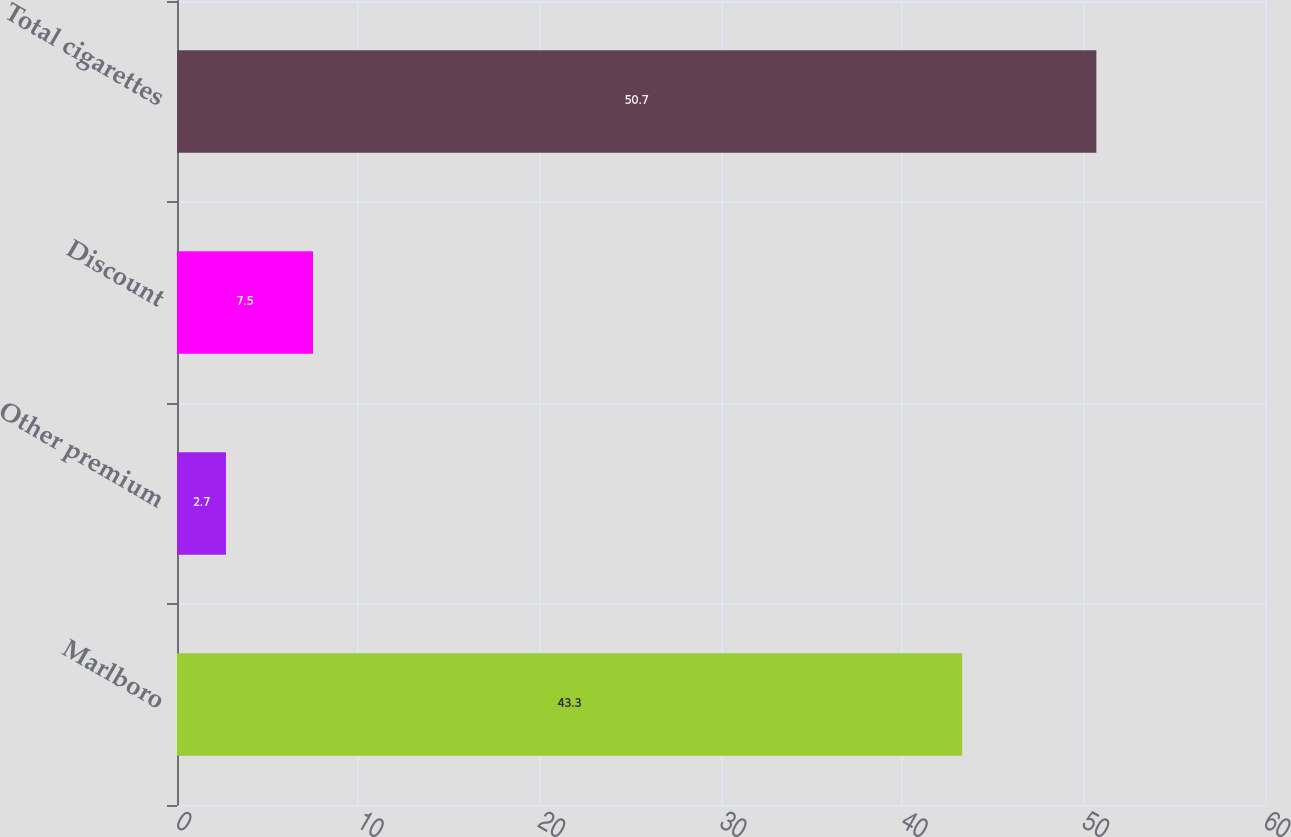Convert chart to OTSL. <chart><loc_0><loc_0><loc_500><loc_500><bar_chart><fcel>Marlboro<fcel>Other premium<fcel>Discount<fcel>Total cigarettes<nl><fcel>43.3<fcel>2.7<fcel>7.5<fcel>50.7<nl></chart> 